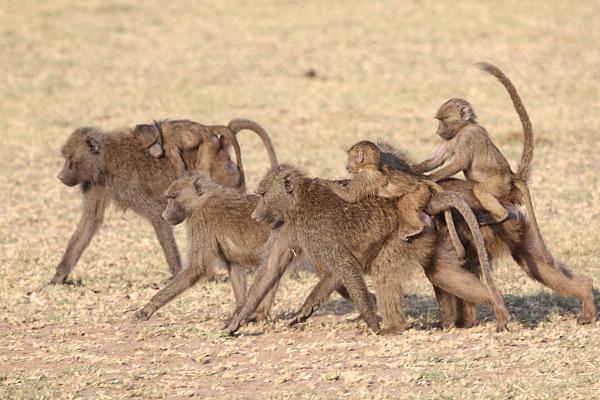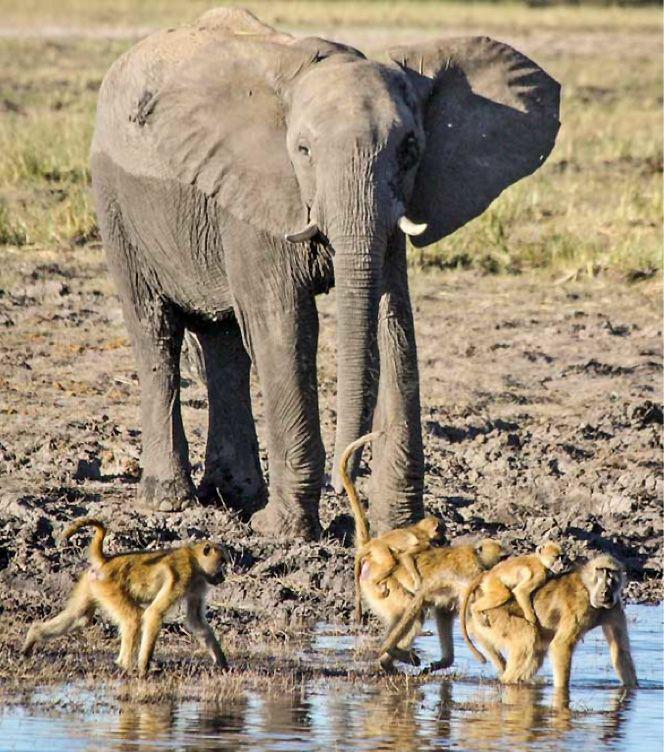The first image is the image on the left, the second image is the image on the right. Considering the images on both sides, is "One ape's teeth are visible." valid? Answer yes or no. No. The first image is the image on the left, the second image is the image on the right. Given the left and right images, does the statement "Each image contains multiple baboons but less than five baboons, and one image includes a baby baboon clinging to the chest of an adult baboon." hold true? Answer yes or no. No. 